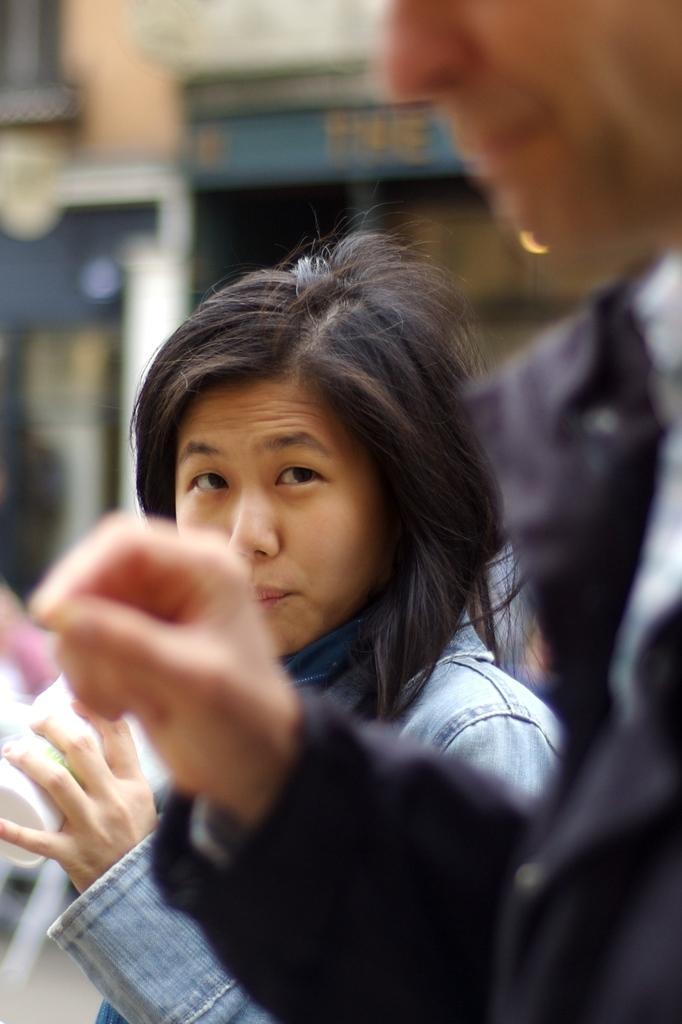Describe this image in one or two sentences. In this image I can see few people and they are wearing different color dresses. Background is blurred. 